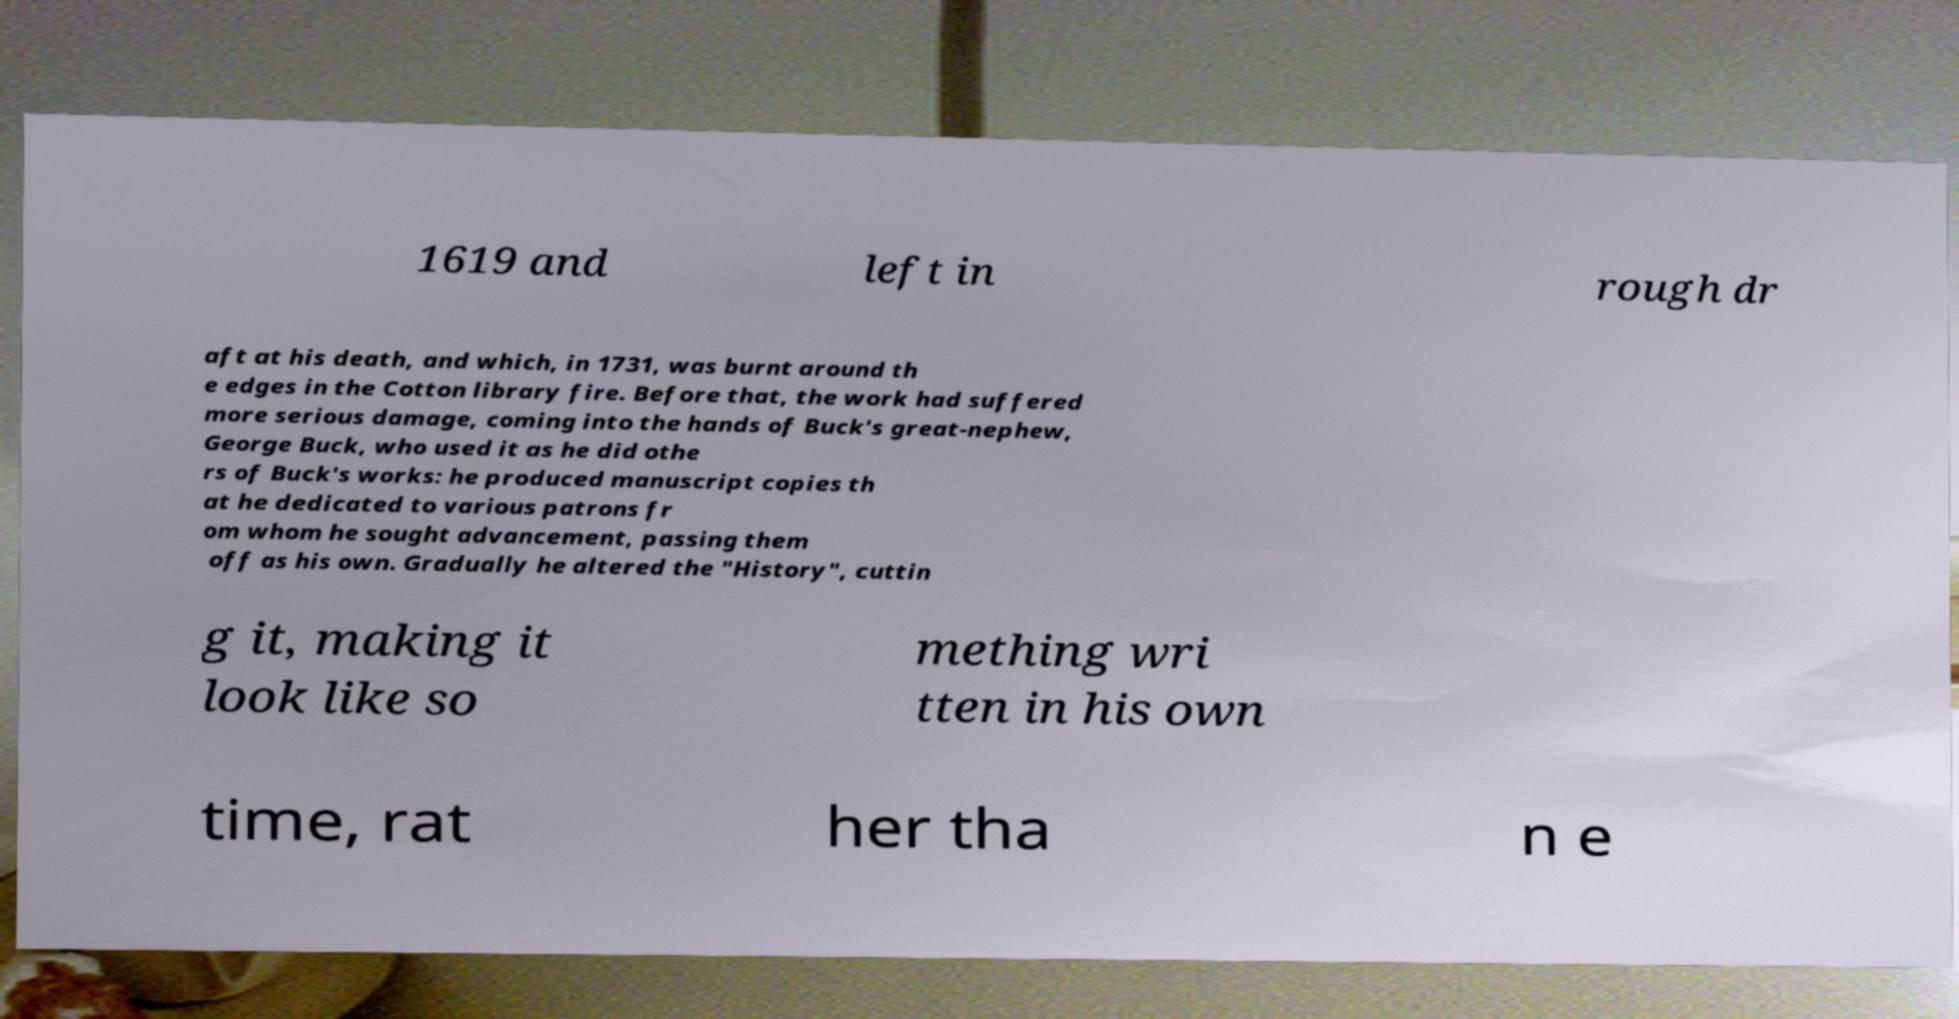Could you assist in decoding the text presented in this image and type it out clearly? 1619 and left in rough dr aft at his death, and which, in 1731, was burnt around th e edges in the Cotton library fire. Before that, the work had suffered more serious damage, coming into the hands of Buck's great-nephew, George Buck, who used it as he did othe rs of Buck's works: he produced manuscript copies th at he dedicated to various patrons fr om whom he sought advancement, passing them off as his own. Gradually he altered the "History", cuttin g it, making it look like so mething wri tten in his own time, rat her tha n e 